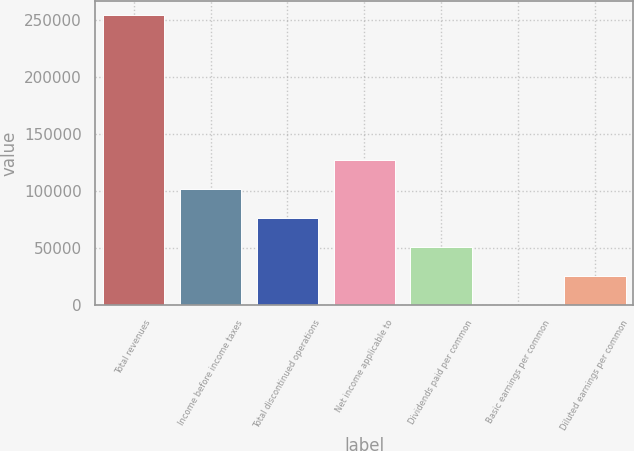Convert chart to OTSL. <chart><loc_0><loc_0><loc_500><loc_500><bar_chart><fcel>Total revenues<fcel>Income before income taxes<fcel>Total discontinued operations<fcel>Net income applicable to<fcel>Dividends paid per common<fcel>Basic earnings per common<fcel>Diluted earnings per common<nl><fcel>254281<fcel>101713<fcel>76284.4<fcel>127141<fcel>50856.4<fcel>0.21<fcel>25428.3<nl></chart> 